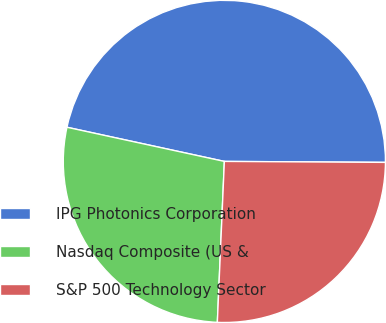Convert chart. <chart><loc_0><loc_0><loc_500><loc_500><pie_chart><fcel>IPG Photonics Corporation<fcel>Nasdaq Composite (US &<fcel>S&P 500 Technology Sector<nl><fcel>46.7%<fcel>27.71%<fcel>25.6%<nl></chart> 